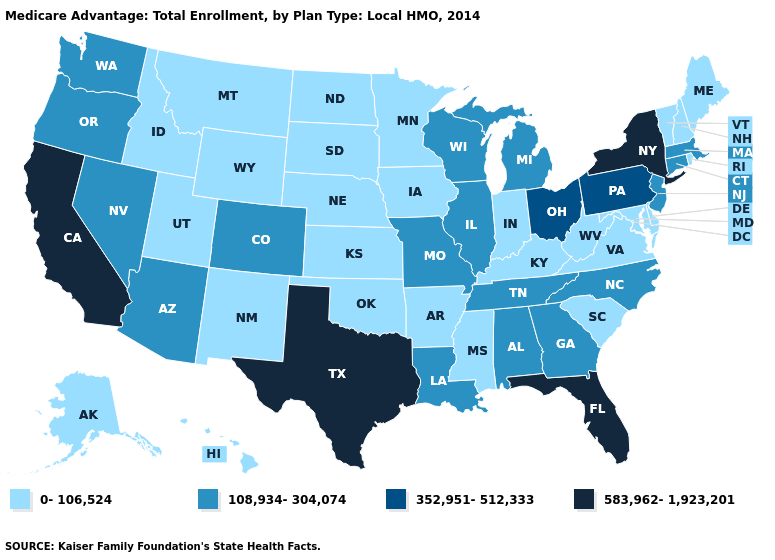Does Michigan have a lower value than New York?
Answer briefly. Yes. What is the lowest value in the USA?
Concise answer only. 0-106,524. Among the states that border Utah , does New Mexico have the highest value?
Concise answer only. No. Name the states that have a value in the range 583,962-1,923,201?
Give a very brief answer. California, Florida, New York, Texas. Is the legend a continuous bar?
Give a very brief answer. No. What is the highest value in the MidWest ?
Keep it brief. 352,951-512,333. What is the value of Kansas?
Give a very brief answer. 0-106,524. Which states have the lowest value in the South?
Answer briefly. Arkansas, Delaware, Kentucky, Maryland, Mississippi, Oklahoma, South Carolina, Virginia, West Virginia. What is the value of Wyoming?
Keep it brief. 0-106,524. Does West Virginia have a lower value than Ohio?
Write a very short answer. Yes. What is the lowest value in the West?
Quick response, please. 0-106,524. Among the states that border Nevada , which have the highest value?
Quick response, please. California. Which states have the lowest value in the MidWest?
Short answer required. Iowa, Indiana, Kansas, Minnesota, North Dakota, Nebraska, South Dakota. What is the highest value in states that border Connecticut?
Answer briefly. 583,962-1,923,201. 